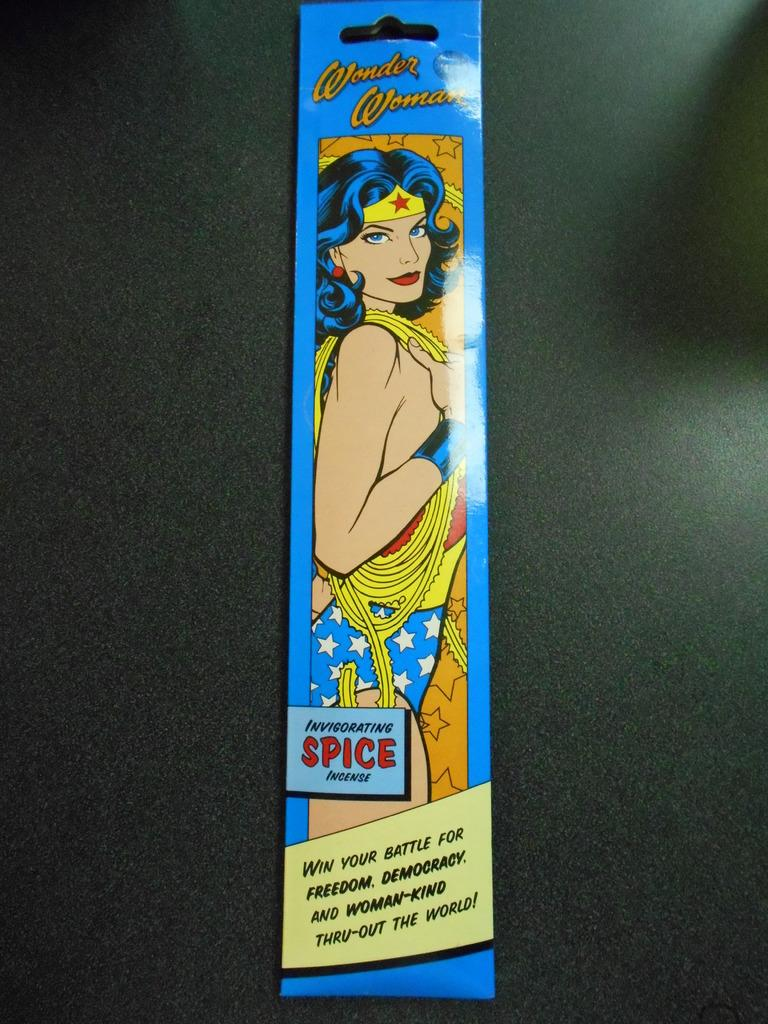What can be found on the card in the image? There are words printed on the card, and there is an image of a woman on the card. What is the card placed on in the image? The card is placed on an object. What type of jelly can be seen on the guitar in the image? There is no jelly or guitar present in the image; it only features a card with words and an image of a woman. --- Facts: 1. There is a person sitting on a chair in the image. 2. The person is holding a book. 3. The book has a blue cover. 4. There is a table next to the chair. 5. The table has a lamp on it. Absurd Topics: elephant, ocean, dance Conversation: What is the person in the image doing? The person is sitting on a chair in the image. What is the person holding in the image? The person is holding a book in the image. What color is the book's cover? The book has a blue cover. What is located next to the chair in the image? There is a table next to the chair in the image. What is on the table in the image? The table has a lamp on it. Reasoning: Let's think step by step in order to produce the conversation. We start by identifying the main subject in the image, which is the person sitting on a chair. Then, we expand the conversation to include other items that are also visible, such as the book, the book's cover color, the table, and the lamp. Each question is designed to elicit a specific detail about the image that is known from the provided facts. Absurd Question/Answer: Can you see an elephant swimming in the ocean in the image? There is no elephant or ocean present in the image; it only features a person sitting on a chair, holding a book, and a table with a lamp. 